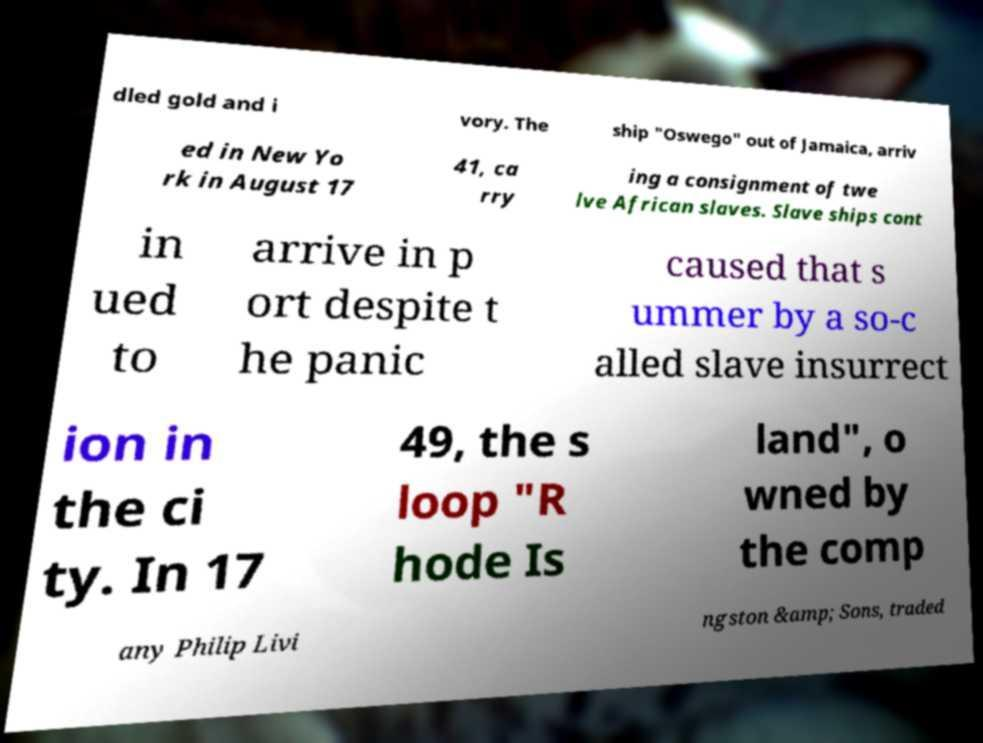Could you assist in decoding the text presented in this image and type it out clearly? dled gold and i vory. The ship "Oswego" out of Jamaica, arriv ed in New Yo rk in August 17 41, ca rry ing a consignment of twe lve African slaves. Slave ships cont in ued to arrive in p ort despite t he panic caused that s ummer by a so-c alled slave insurrect ion in the ci ty. In 17 49, the s loop "R hode Is land", o wned by the comp any Philip Livi ngston &amp; Sons, traded 